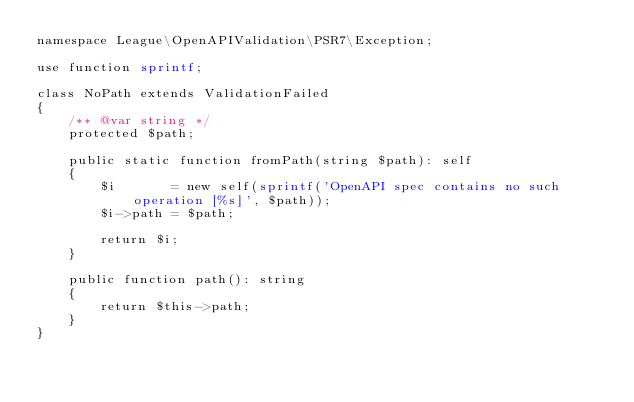Convert code to text. <code><loc_0><loc_0><loc_500><loc_500><_PHP_>namespace League\OpenAPIValidation\PSR7\Exception;

use function sprintf;

class NoPath extends ValidationFailed
{
    /** @var string */
    protected $path;

    public static function fromPath(string $path): self
    {
        $i       = new self(sprintf('OpenAPI spec contains no such operation [%s]', $path));
        $i->path = $path;

        return $i;
    }

    public function path(): string
    {
        return $this->path;
    }
}
</code> 